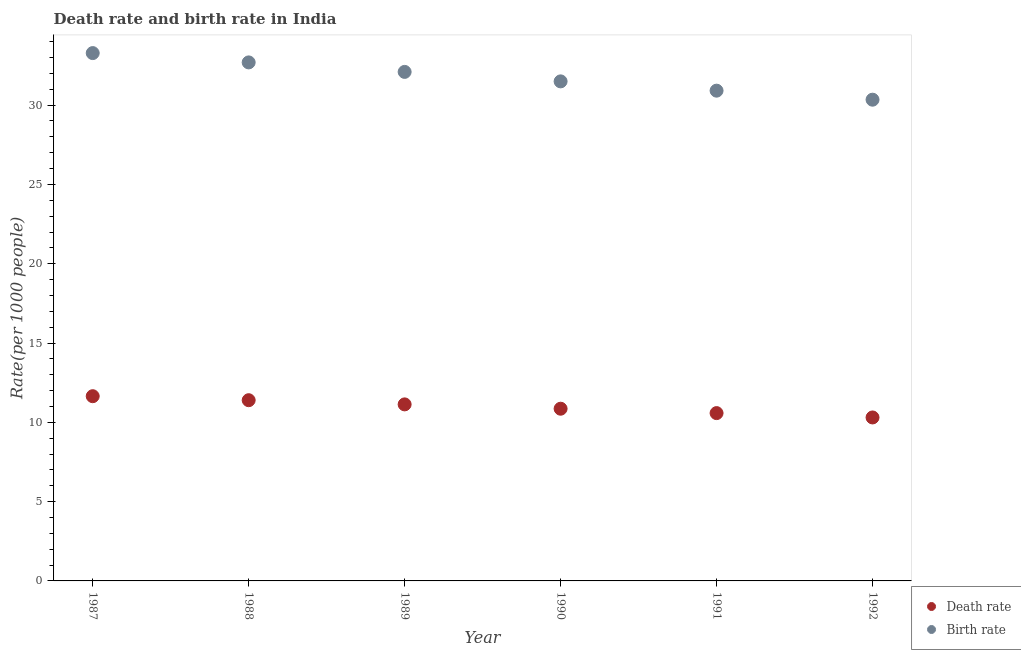What is the birth rate in 1991?
Make the answer very short. 30.91. Across all years, what is the maximum birth rate?
Offer a very short reply. 33.28. Across all years, what is the minimum birth rate?
Your answer should be compact. 30.34. In which year was the death rate maximum?
Ensure brevity in your answer.  1987. What is the total death rate in the graph?
Offer a terse response. 65.92. What is the difference between the birth rate in 1989 and that in 1991?
Offer a terse response. 1.18. What is the difference between the birth rate in 1989 and the death rate in 1987?
Make the answer very short. 20.45. What is the average death rate per year?
Make the answer very short. 10.99. In the year 1992, what is the difference between the birth rate and death rate?
Provide a succinct answer. 20.04. What is the ratio of the death rate in 1987 to that in 1989?
Keep it short and to the point. 1.05. Is the birth rate in 1987 less than that in 1992?
Your response must be concise. No. Is the difference between the death rate in 1988 and 1990 greater than the difference between the birth rate in 1988 and 1990?
Your response must be concise. No. What is the difference between the highest and the second highest birth rate?
Give a very brief answer. 0.59. What is the difference between the highest and the lowest birth rate?
Give a very brief answer. 2.94. Does the death rate monotonically increase over the years?
Offer a terse response. No. Is the birth rate strictly less than the death rate over the years?
Offer a terse response. No. How many dotlines are there?
Your response must be concise. 2. How many years are there in the graph?
Ensure brevity in your answer.  6. What is the difference between two consecutive major ticks on the Y-axis?
Your response must be concise. 5. Are the values on the major ticks of Y-axis written in scientific E-notation?
Your answer should be very brief. No. How many legend labels are there?
Provide a short and direct response. 2. How are the legend labels stacked?
Give a very brief answer. Vertical. What is the title of the graph?
Your answer should be very brief. Death rate and birth rate in India. Does "Urban Population" appear as one of the legend labels in the graph?
Provide a short and direct response. No. What is the label or title of the Y-axis?
Your answer should be compact. Rate(per 1000 people). What is the Rate(per 1000 people) of Death rate in 1987?
Offer a terse response. 11.65. What is the Rate(per 1000 people) in Birth rate in 1987?
Ensure brevity in your answer.  33.28. What is the Rate(per 1000 people) of Death rate in 1988?
Provide a succinct answer. 11.39. What is the Rate(per 1000 people) in Birth rate in 1988?
Offer a very short reply. 32.69. What is the Rate(per 1000 people) of Death rate in 1989?
Provide a short and direct response. 11.13. What is the Rate(per 1000 people) of Birth rate in 1989?
Provide a succinct answer. 32.09. What is the Rate(per 1000 people) in Death rate in 1990?
Give a very brief answer. 10.86. What is the Rate(per 1000 people) of Birth rate in 1990?
Your answer should be very brief. 31.5. What is the Rate(per 1000 people) in Death rate in 1991?
Provide a short and direct response. 10.58. What is the Rate(per 1000 people) of Birth rate in 1991?
Make the answer very short. 30.91. What is the Rate(per 1000 people) of Death rate in 1992?
Give a very brief answer. 10.31. What is the Rate(per 1000 people) of Birth rate in 1992?
Your response must be concise. 30.34. Across all years, what is the maximum Rate(per 1000 people) in Death rate?
Offer a terse response. 11.65. Across all years, what is the maximum Rate(per 1000 people) of Birth rate?
Provide a succinct answer. 33.28. Across all years, what is the minimum Rate(per 1000 people) in Death rate?
Your answer should be compact. 10.31. Across all years, what is the minimum Rate(per 1000 people) in Birth rate?
Give a very brief answer. 30.34. What is the total Rate(per 1000 people) in Death rate in the graph?
Give a very brief answer. 65.92. What is the total Rate(per 1000 people) of Birth rate in the graph?
Your answer should be very brief. 190.82. What is the difference between the Rate(per 1000 people) in Death rate in 1987 and that in 1988?
Your answer should be compact. 0.25. What is the difference between the Rate(per 1000 people) in Birth rate in 1987 and that in 1988?
Keep it short and to the point. 0.59. What is the difference between the Rate(per 1000 people) of Death rate in 1987 and that in 1989?
Your response must be concise. 0.52. What is the difference between the Rate(per 1000 people) in Birth rate in 1987 and that in 1989?
Ensure brevity in your answer.  1.19. What is the difference between the Rate(per 1000 people) in Death rate in 1987 and that in 1990?
Provide a succinct answer. 0.79. What is the difference between the Rate(per 1000 people) of Birth rate in 1987 and that in 1990?
Offer a very short reply. 1.78. What is the difference between the Rate(per 1000 people) of Death rate in 1987 and that in 1991?
Keep it short and to the point. 1.07. What is the difference between the Rate(per 1000 people) of Birth rate in 1987 and that in 1991?
Your answer should be very brief. 2.37. What is the difference between the Rate(per 1000 people) in Death rate in 1987 and that in 1992?
Offer a very short reply. 1.34. What is the difference between the Rate(per 1000 people) of Birth rate in 1987 and that in 1992?
Ensure brevity in your answer.  2.94. What is the difference between the Rate(per 1000 people) of Death rate in 1988 and that in 1989?
Your response must be concise. 0.26. What is the difference between the Rate(per 1000 people) in Birth rate in 1988 and that in 1989?
Offer a terse response. 0.6. What is the difference between the Rate(per 1000 people) of Death rate in 1988 and that in 1990?
Offer a terse response. 0.54. What is the difference between the Rate(per 1000 people) of Birth rate in 1988 and that in 1990?
Offer a terse response. 1.2. What is the difference between the Rate(per 1000 people) of Death rate in 1988 and that in 1991?
Your answer should be compact. 0.81. What is the difference between the Rate(per 1000 people) of Birth rate in 1988 and that in 1991?
Ensure brevity in your answer.  1.78. What is the difference between the Rate(per 1000 people) in Death rate in 1988 and that in 1992?
Your answer should be very brief. 1.09. What is the difference between the Rate(per 1000 people) in Birth rate in 1988 and that in 1992?
Give a very brief answer. 2.35. What is the difference between the Rate(per 1000 people) in Death rate in 1989 and that in 1990?
Make the answer very short. 0.27. What is the difference between the Rate(per 1000 people) of Birth rate in 1989 and that in 1990?
Offer a very short reply. 0.6. What is the difference between the Rate(per 1000 people) in Death rate in 1989 and that in 1991?
Keep it short and to the point. 0.55. What is the difference between the Rate(per 1000 people) in Birth rate in 1989 and that in 1991?
Give a very brief answer. 1.18. What is the difference between the Rate(per 1000 people) in Death rate in 1989 and that in 1992?
Ensure brevity in your answer.  0.82. What is the difference between the Rate(per 1000 people) in Birth rate in 1989 and that in 1992?
Offer a terse response. 1.75. What is the difference between the Rate(per 1000 people) of Death rate in 1990 and that in 1991?
Make the answer very short. 0.28. What is the difference between the Rate(per 1000 people) in Birth rate in 1990 and that in 1991?
Offer a very short reply. 0.59. What is the difference between the Rate(per 1000 people) in Death rate in 1990 and that in 1992?
Offer a very short reply. 0.55. What is the difference between the Rate(per 1000 people) of Birth rate in 1990 and that in 1992?
Provide a succinct answer. 1.16. What is the difference between the Rate(per 1000 people) of Death rate in 1991 and that in 1992?
Offer a very short reply. 0.27. What is the difference between the Rate(per 1000 people) of Birth rate in 1991 and that in 1992?
Provide a short and direct response. 0.57. What is the difference between the Rate(per 1000 people) of Death rate in 1987 and the Rate(per 1000 people) of Birth rate in 1988?
Provide a succinct answer. -21.05. What is the difference between the Rate(per 1000 people) of Death rate in 1987 and the Rate(per 1000 people) of Birth rate in 1989?
Make the answer very short. -20.45. What is the difference between the Rate(per 1000 people) of Death rate in 1987 and the Rate(per 1000 people) of Birth rate in 1990?
Provide a succinct answer. -19.85. What is the difference between the Rate(per 1000 people) in Death rate in 1987 and the Rate(per 1000 people) in Birth rate in 1991?
Your answer should be compact. -19.27. What is the difference between the Rate(per 1000 people) in Death rate in 1987 and the Rate(per 1000 people) in Birth rate in 1992?
Ensure brevity in your answer.  -18.7. What is the difference between the Rate(per 1000 people) of Death rate in 1988 and the Rate(per 1000 people) of Birth rate in 1989?
Provide a short and direct response. -20.7. What is the difference between the Rate(per 1000 people) in Death rate in 1988 and the Rate(per 1000 people) in Birth rate in 1990?
Provide a succinct answer. -20.1. What is the difference between the Rate(per 1000 people) in Death rate in 1988 and the Rate(per 1000 people) in Birth rate in 1991?
Your response must be concise. -19.52. What is the difference between the Rate(per 1000 people) in Death rate in 1988 and the Rate(per 1000 people) in Birth rate in 1992?
Your answer should be very brief. -18.95. What is the difference between the Rate(per 1000 people) of Death rate in 1989 and the Rate(per 1000 people) of Birth rate in 1990?
Provide a succinct answer. -20.37. What is the difference between the Rate(per 1000 people) in Death rate in 1989 and the Rate(per 1000 people) in Birth rate in 1991?
Ensure brevity in your answer.  -19.78. What is the difference between the Rate(per 1000 people) of Death rate in 1989 and the Rate(per 1000 people) of Birth rate in 1992?
Provide a succinct answer. -19.21. What is the difference between the Rate(per 1000 people) in Death rate in 1990 and the Rate(per 1000 people) in Birth rate in 1991?
Provide a succinct answer. -20.05. What is the difference between the Rate(per 1000 people) in Death rate in 1990 and the Rate(per 1000 people) in Birth rate in 1992?
Your response must be concise. -19.48. What is the difference between the Rate(per 1000 people) in Death rate in 1991 and the Rate(per 1000 people) in Birth rate in 1992?
Provide a succinct answer. -19.76. What is the average Rate(per 1000 people) of Death rate per year?
Your answer should be compact. 10.99. What is the average Rate(per 1000 people) in Birth rate per year?
Provide a succinct answer. 31.8. In the year 1987, what is the difference between the Rate(per 1000 people) of Death rate and Rate(per 1000 people) of Birth rate?
Offer a very short reply. -21.63. In the year 1988, what is the difference between the Rate(per 1000 people) of Death rate and Rate(per 1000 people) of Birth rate?
Provide a succinct answer. -21.3. In the year 1989, what is the difference between the Rate(per 1000 people) of Death rate and Rate(per 1000 people) of Birth rate?
Your answer should be very brief. -20.96. In the year 1990, what is the difference between the Rate(per 1000 people) in Death rate and Rate(per 1000 people) in Birth rate?
Offer a very short reply. -20.64. In the year 1991, what is the difference between the Rate(per 1000 people) in Death rate and Rate(per 1000 people) in Birth rate?
Keep it short and to the point. -20.33. In the year 1992, what is the difference between the Rate(per 1000 people) in Death rate and Rate(per 1000 people) in Birth rate?
Offer a terse response. -20.04. What is the ratio of the Rate(per 1000 people) in Death rate in 1987 to that in 1988?
Your answer should be very brief. 1.02. What is the ratio of the Rate(per 1000 people) of Birth rate in 1987 to that in 1988?
Make the answer very short. 1.02. What is the ratio of the Rate(per 1000 people) in Death rate in 1987 to that in 1989?
Provide a succinct answer. 1.05. What is the ratio of the Rate(per 1000 people) of Death rate in 1987 to that in 1990?
Offer a very short reply. 1.07. What is the ratio of the Rate(per 1000 people) in Birth rate in 1987 to that in 1990?
Make the answer very short. 1.06. What is the ratio of the Rate(per 1000 people) in Death rate in 1987 to that in 1991?
Keep it short and to the point. 1.1. What is the ratio of the Rate(per 1000 people) in Birth rate in 1987 to that in 1991?
Offer a very short reply. 1.08. What is the ratio of the Rate(per 1000 people) in Death rate in 1987 to that in 1992?
Provide a succinct answer. 1.13. What is the ratio of the Rate(per 1000 people) of Birth rate in 1987 to that in 1992?
Your answer should be compact. 1.1. What is the ratio of the Rate(per 1000 people) of Death rate in 1988 to that in 1989?
Your response must be concise. 1.02. What is the ratio of the Rate(per 1000 people) of Birth rate in 1988 to that in 1989?
Your answer should be very brief. 1.02. What is the ratio of the Rate(per 1000 people) in Death rate in 1988 to that in 1990?
Offer a very short reply. 1.05. What is the ratio of the Rate(per 1000 people) in Birth rate in 1988 to that in 1990?
Offer a very short reply. 1.04. What is the ratio of the Rate(per 1000 people) of Birth rate in 1988 to that in 1991?
Provide a succinct answer. 1.06. What is the ratio of the Rate(per 1000 people) of Death rate in 1988 to that in 1992?
Ensure brevity in your answer.  1.11. What is the ratio of the Rate(per 1000 people) of Birth rate in 1988 to that in 1992?
Give a very brief answer. 1.08. What is the ratio of the Rate(per 1000 people) of Death rate in 1989 to that in 1990?
Offer a terse response. 1.03. What is the ratio of the Rate(per 1000 people) of Death rate in 1989 to that in 1991?
Give a very brief answer. 1.05. What is the ratio of the Rate(per 1000 people) of Birth rate in 1989 to that in 1991?
Ensure brevity in your answer.  1.04. What is the ratio of the Rate(per 1000 people) of Death rate in 1989 to that in 1992?
Make the answer very short. 1.08. What is the ratio of the Rate(per 1000 people) in Birth rate in 1989 to that in 1992?
Give a very brief answer. 1.06. What is the ratio of the Rate(per 1000 people) of Death rate in 1990 to that in 1991?
Keep it short and to the point. 1.03. What is the ratio of the Rate(per 1000 people) in Birth rate in 1990 to that in 1991?
Keep it short and to the point. 1.02. What is the ratio of the Rate(per 1000 people) in Death rate in 1990 to that in 1992?
Provide a succinct answer. 1.05. What is the ratio of the Rate(per 1000 people) in Birth rate in 1990 to that in 1992?
Provide a succinct answer. 1.04. What is the ratio of the Rate(per 1000 people) in Death rate in 1991 to that in 1992?
Provide a succinct answer. 1.03. What is the ratio of the Rate(per 1000 people) in Birth rate in 1991 to that in 1992?
Ensure brevity in your answer.  1.02. What is the difference between the highest and the second highest Rate(per 1000 people) in Death rate?
Provide a short and direct response. 0.25. What is the difference between the highest and the second highest Rate(per 1000 people) of Birth rate?
Your answer should be very brief. 0.59. What is the difference between the highest and the lowest Rate(per 1000 people) of Death rate?
Ensure brevity in your answer.  1.34. What is the difference between the highest and the lowest Rate(per 1000 people) of Birth rate?
Your answer should be very brief. 2.94. 